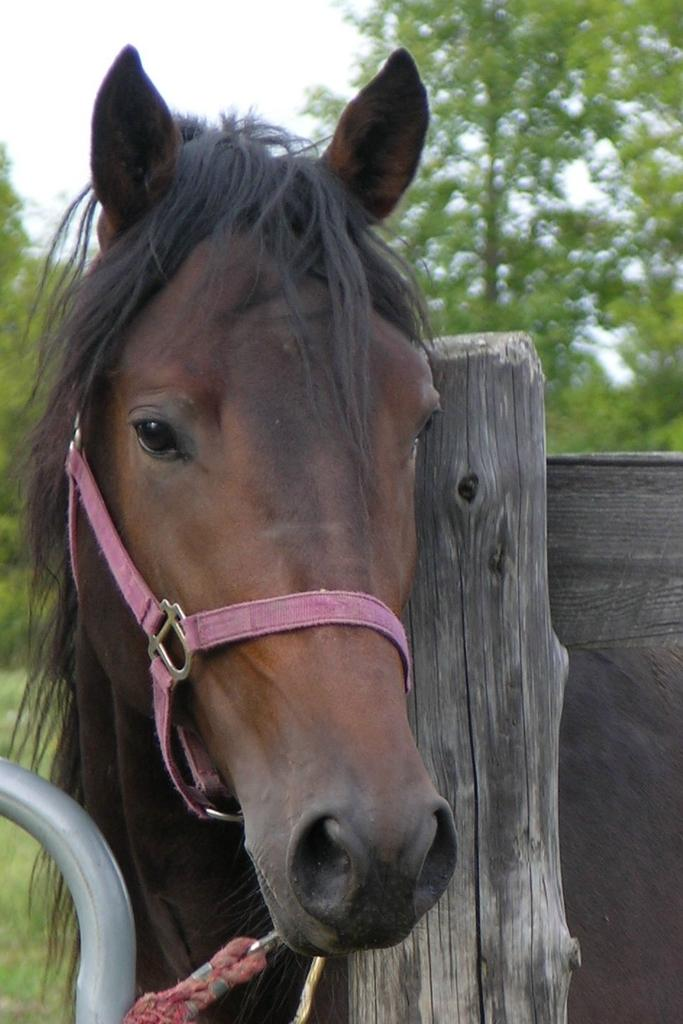What animal is present in the image? There is a horse in the image. What object resembles a fence in the image? There is a wooden log that resembles a fence in the image. What type of natural environment can be seen in the background of the image? There are trees visible in the background of the image. Where is the house located in the image? There is no house present in the image. What type of drain can be seen in the image? There is no drain present in the image. 